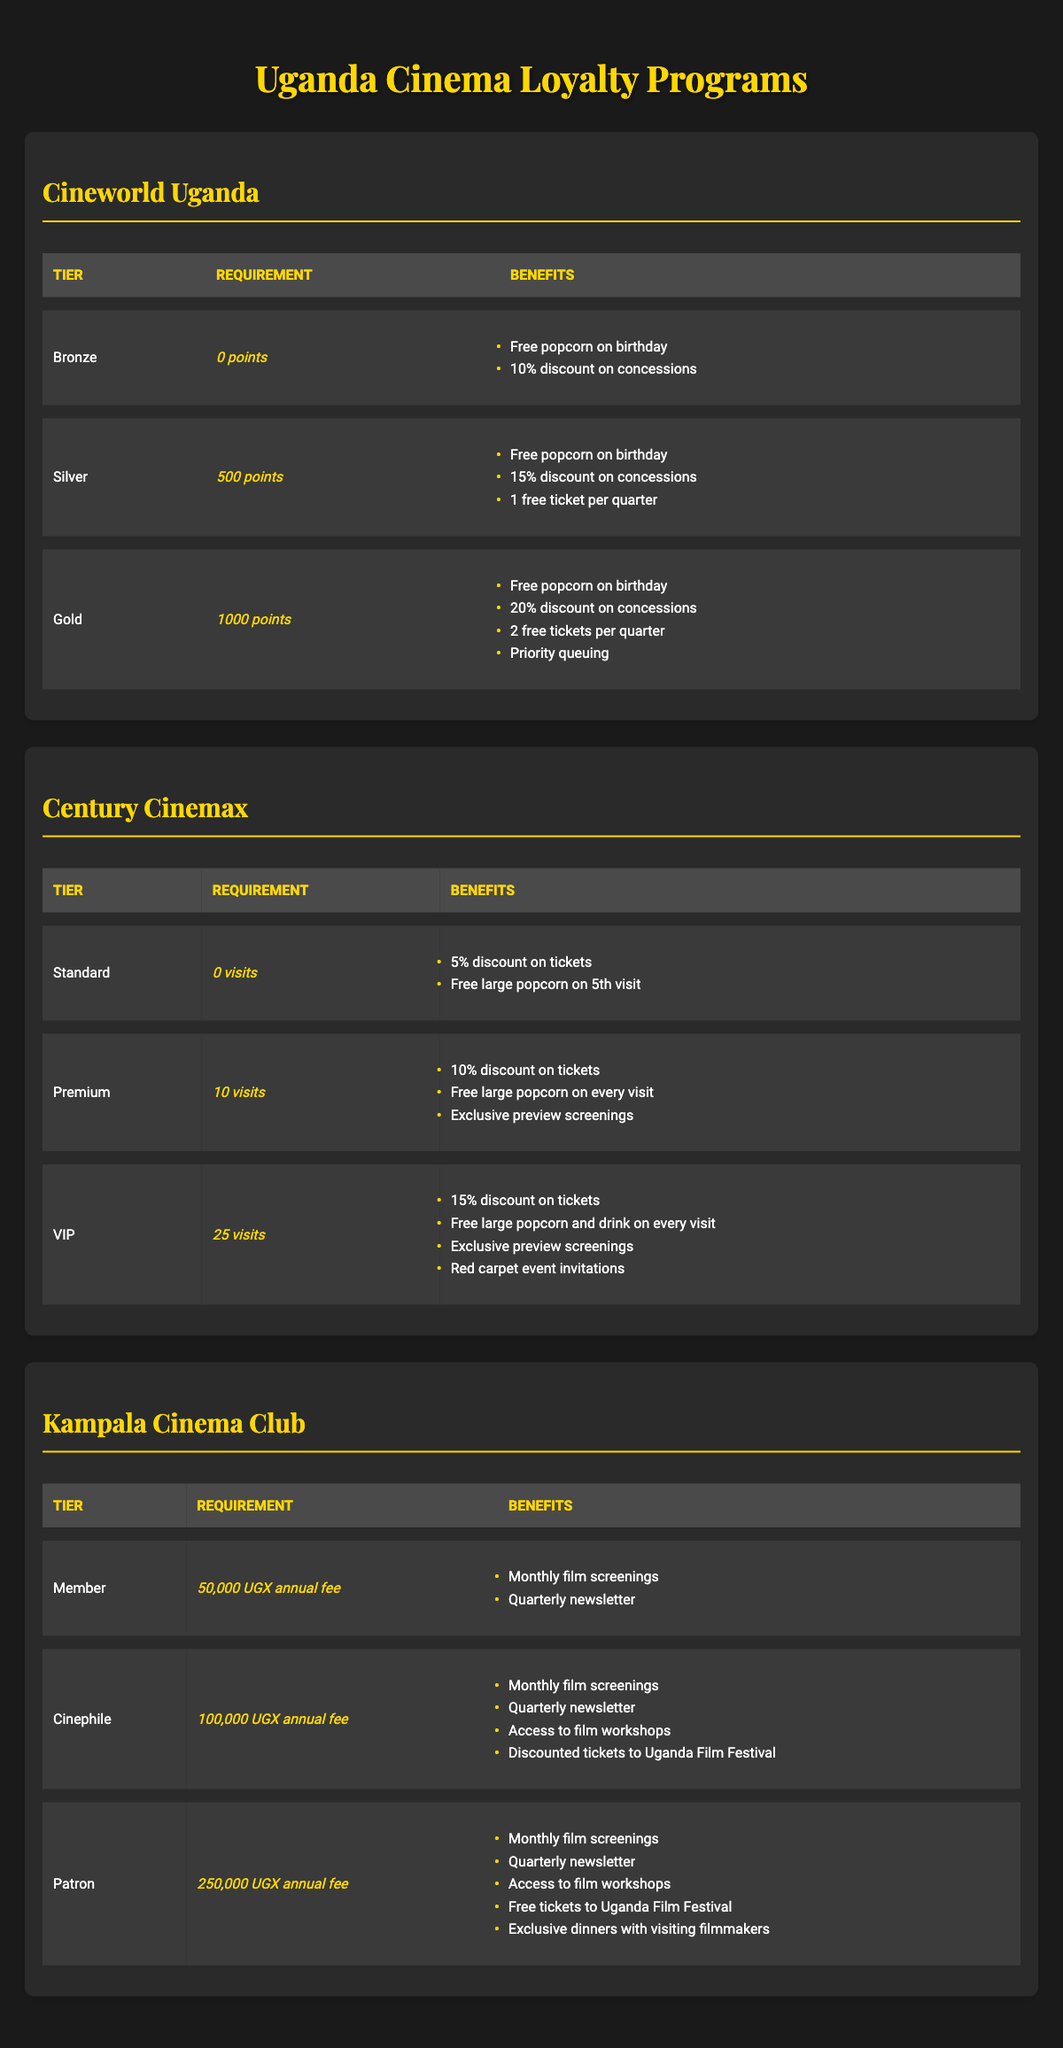What are the benefits of the Gold tier in Cineworld Uganda? The Gold tier offers four benefits: Free popcorn on birthday, 20% discount on concessions, 2 free tickets per quarter, and Priority queuing. These benefits can be found listed under the Gold tier in the table.
Answer: Free popcorn on birthday, 20% discount on concessions, 2 free tickets per quarter, Priority queuing How many points are required to achieve the Silver tier in Cineworld Uganda? To find the points required for the Silver tier, we look under the requirements column of the Silver tier, which specifies 500 points.
Answer: 500 points Does the VIP tier in Century Cinemax include invitations to red carpet events? The benefits listed for the VIP tier include red carpet event invitations, confirming that this is true.
Answer: Yes What is the total annual fee to reach the Patron tier in Kampala Cinema Club? The fee for the Patron tier is 250,000 UGX. This figure is found directly in the requirements column for the Patron row in the table.
Answer: 250,000 UGX How many free tickets do you receive per quarter in the Silver tier of Cineworld Uganda compared to the Gold tier? The Silver tier provides 1 free ticket per quarter, whereas the Gold tier offers 2 free tickets per quarter. Comparing these values shows that the Gold tier benefits are greater.
Answer: Gold tier offers 2 tickets, Silver tier offers 1 ticket Are the benefits of the Premium tier in Century Cinemax better than the Standard tier? The Premium tier includes a 10% discount on tickets, free large popcorn on every visit, and exclusive preview screenings. The Standard tier only offers a 5% discount and a free large popcorn on the 5th visit. This shows that the Premium tier has superior benefits than the Standard tier.
Answer: Yes What is the difference in points required between the Bronze and Gold tiers in Cineworld Uganda? The Bronze tier requires 0 points while the Gold tier requires 1000 points. The difference is calculated by subtracting the points of the Bronze tier from the Gold tier: 1000 - 0 = 1000.
Answer: 1000 points If a member visits Century Cinemax 25 times, what tier will they achieve? The VIP tier requires 25 visits, which means if a member visits this number of times, they will be in the VIP tier. The requirement for the VIP tier in Century Cinemax is explicitly 25 visits.
Answer: VIP tier What benefits do you receive as a Member in Kampala Cinema Club? The Member tier provides two benefits: Monthly film screenings and a quarterly newsletter. These can be found listed under the benefits of the Member tier in the table.
Answer: Monthly film screenings, Quarterly newsletter 